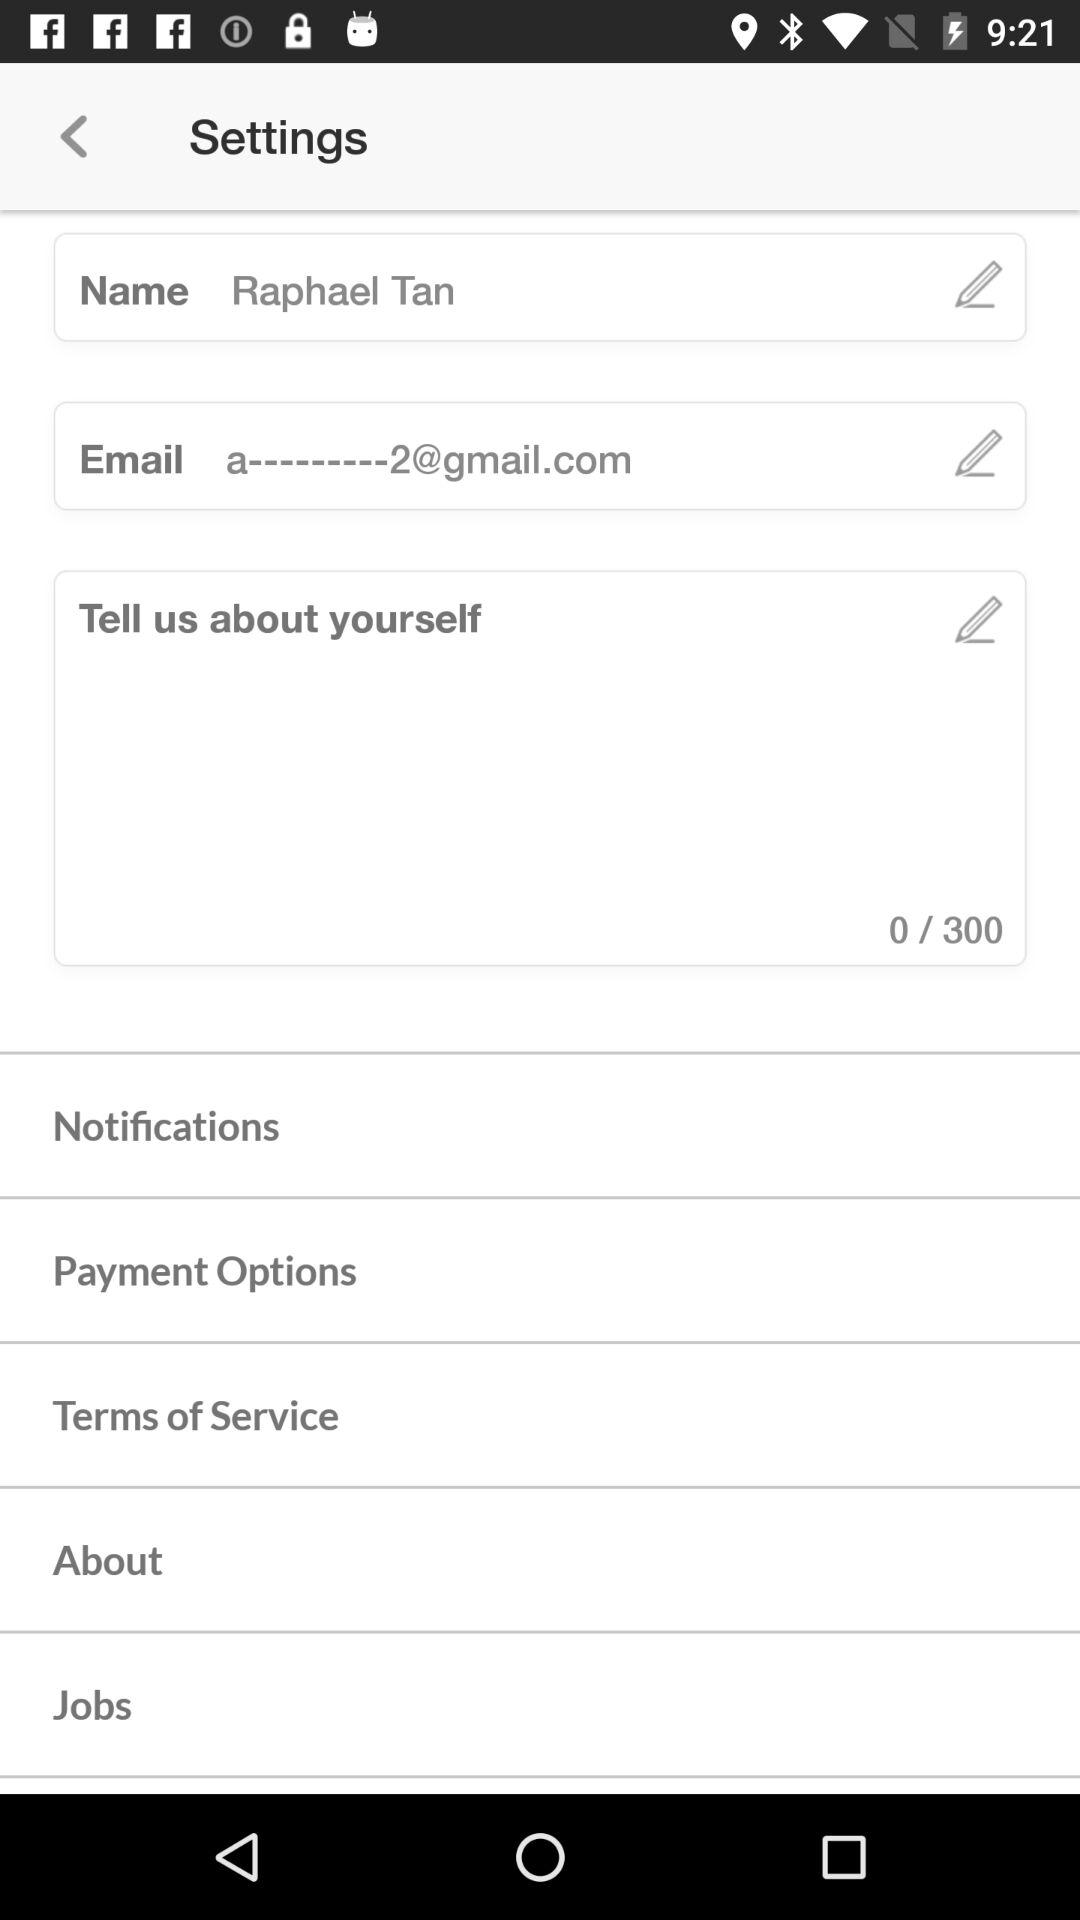What is the email address?
Answer the question using a single word or phrase. The email address is a---------2@gmail.com 